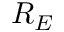<formula> <loc_0><loc_0><loc_500><loc_500>R _ { E }</formula> 